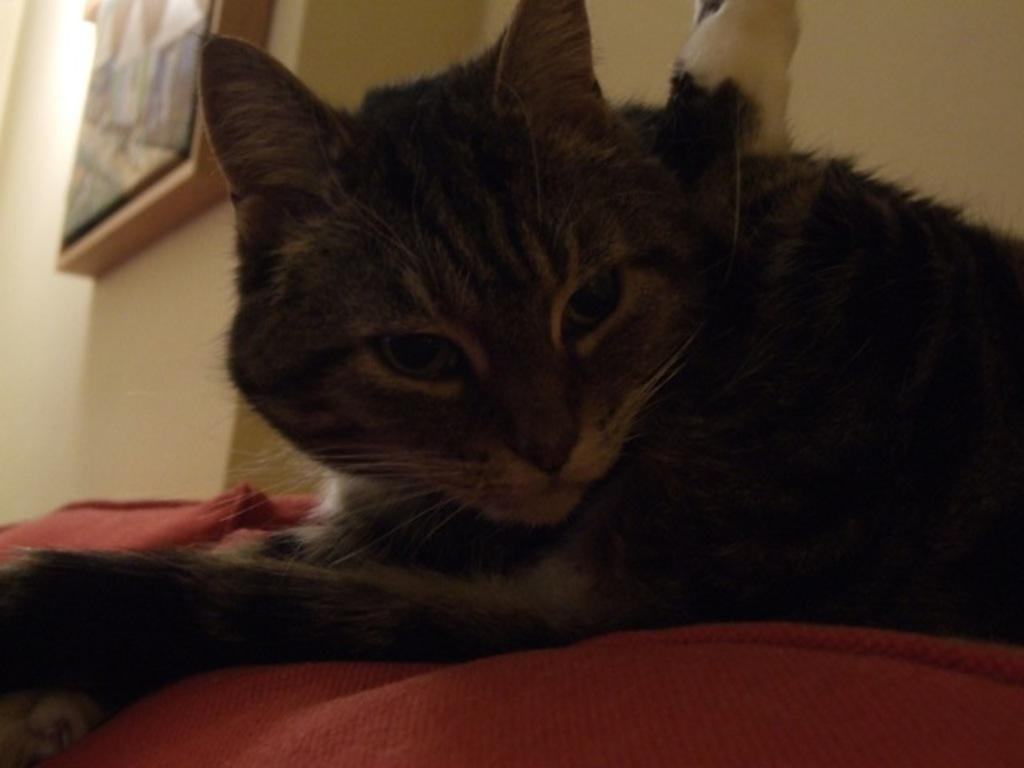What animal is present in the image? There is a cat in the image. What is the cat sitting or lying on? The cat is on a cloth. What can be seen on the wall in the background of the image? There is a frame on the wall in the background of the image. What type of glue is the cat using to make a discovery in the image? There is no glue or discovery activity present in the image; it features a cat on a cloth with a frame on the wall in the background. 